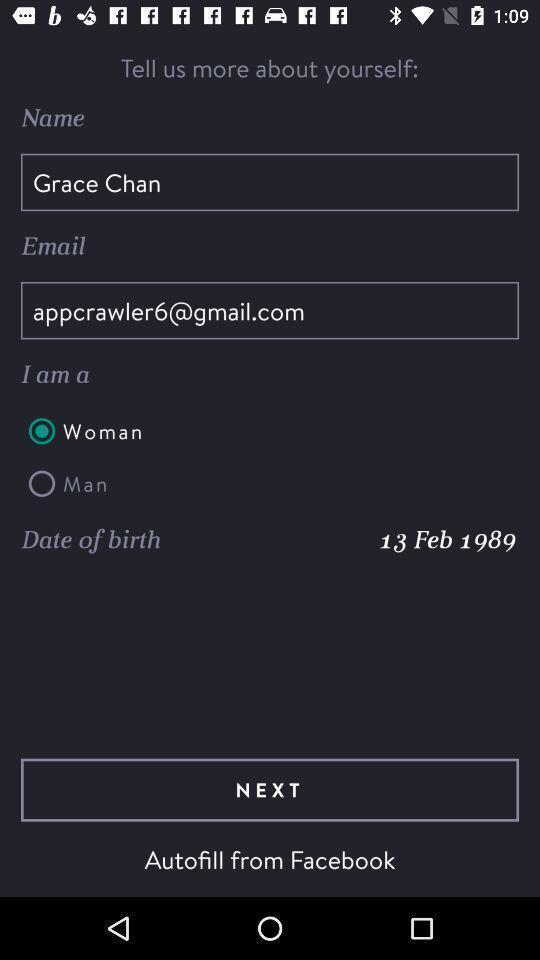Give me a summary of this screen capture. Page displaying to fill personal details. 